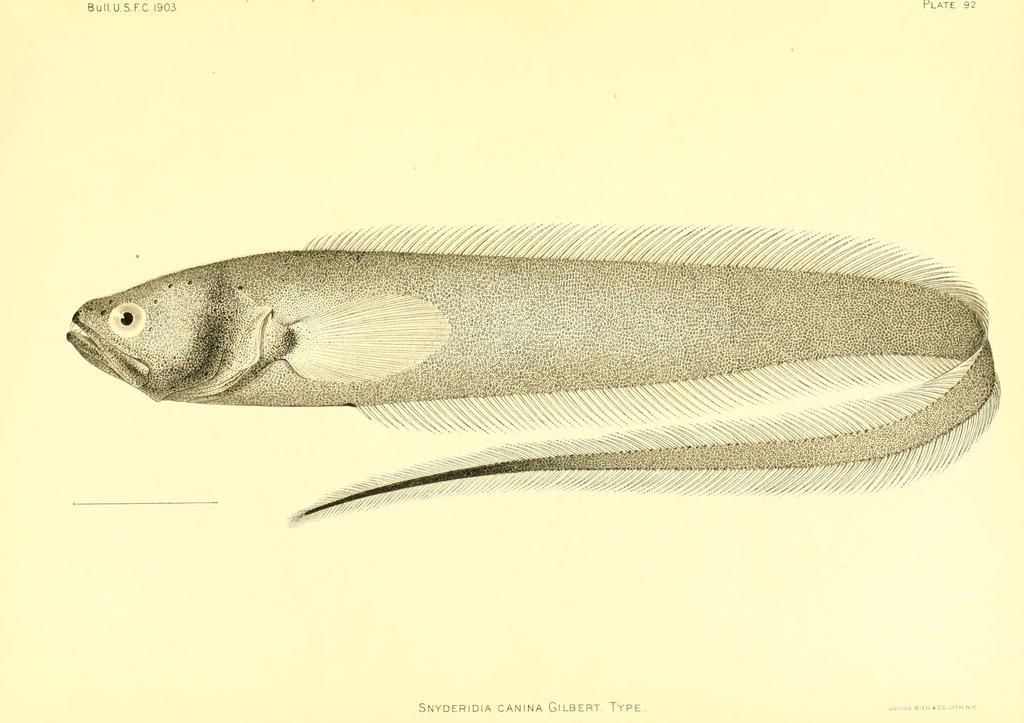What is the main subject of the image? There is a depiction of a fish in the center of the image. What else can be seen in the image besides the fish? There is text at the bottom of the image on a paper. What type of smell is associated with the fish in the image? There is no smell associated with the fish in the image, as it is a two-dimensional depiction. 